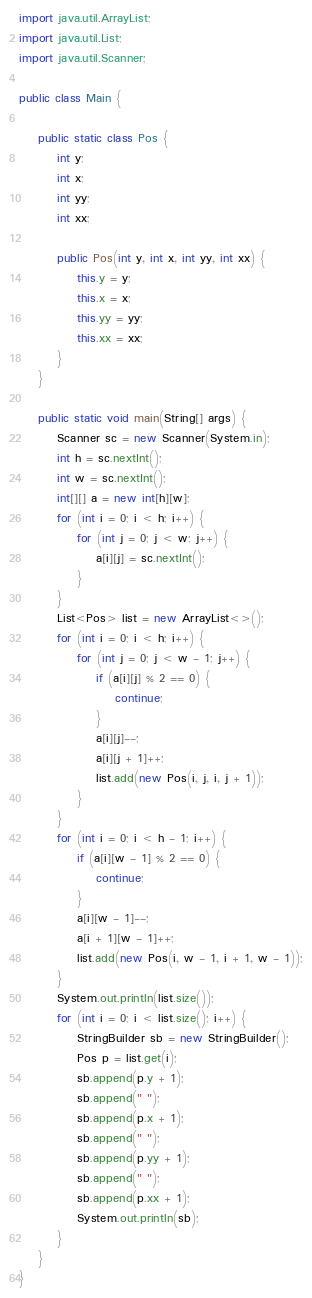Convert code to text. <code><loc_0><loc_0><loc_500><loc_500><_Java_>import java.util.ArrayList;
import java.util.List;
import java.util.Scanner;

public class Main {

    public static class Pos {
        int y;
        int x;
        int yy;
        int xx;

        public Pos(int y, int x, int yy, int xx) {
            this.y = y;
            this.x = x;
            this.yy = yy;
            this.xx = xx;
        }
    }

    public static void main(String[] args) {
        Scanner sc = new Scanner(System.in);
        int h = sc.nextInt();
        int w = sc.nextInt();
        int[][] a = new int[h][w];
        for (int i = 0; i < h; i++) {
            for (int j = 0; j < w; j++) {
                a[i][j] = sc.nextInt();
            }
        }
        List<Pos> list = new ArrayList<>();
        for (int i = 0; i < h; i++) {
            for (int j = 0; j < w - 1; j++) {
                if (a[i][j] % 2 == 0) {
                    continue;
                }
                a[i][j]--;
                a[i][j + 1]++;
                list.add(new Pos(i, j, i, j + 1));
            }
        }
        for (int i = 0; i < h - 1; i++) {
            if (a[i][w - 1] % 2 == 0) {
                continue;
            }
            a[i][w - 1]--;
            a[i + 1][w - 1]++;
            list.add(new Pos(i, w - 1, i + 1, w - 1));
        }
        System.out.println(list.size());
        for (int i = 0; i < list.size(); i++) {
            StringBuilder sb = new StringBuilder();
            Pos p = list.get(i);
            sb.append(p.y + 1);
            sb.append(" ");
            sb.append(p.x + 1);
            sb.append(" ");
            sb.append(p.yy + 1);
            sb.append(" ");
            sb.append(p.xx + 1);
            System.out.println(sb);
        }
    }
}
</code> 